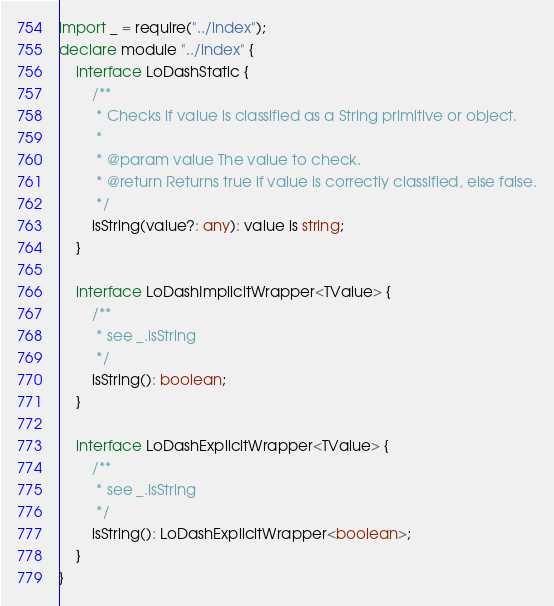Convert code to text. <code><loc_0><loc_0><loc_500><loc_500><_TypeScript_>import _ = require("../index");
declare module "../index" {
    interface LoDashStatic {
        /**
         * Checks if value is classified as a String primitive or object.
         *
         * @param value The value to check.
         * @return Returns true if value is correctly classified, else false.
         */
        isString(value?: any): value is string;
    }

    interface LoDashImplicitWrapper<TValue> {
        /**
         * see _.isString
         */
        isString(): boolean;
    }

    interface LoDashExplicitWrapper<TValue> {
        /**
         * see _.isString
         */
        isString(): LoDashExplicitWrapper<boolean>;
    }
}</code> 